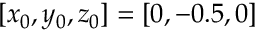<formula> <loc_0><loc_0><loc_500><loc_500>[ x _ { 0 } , y _ { 0 } , z _ { 0 } ] = [ 0 , - 0 . 5 , 0 ]</formula> 